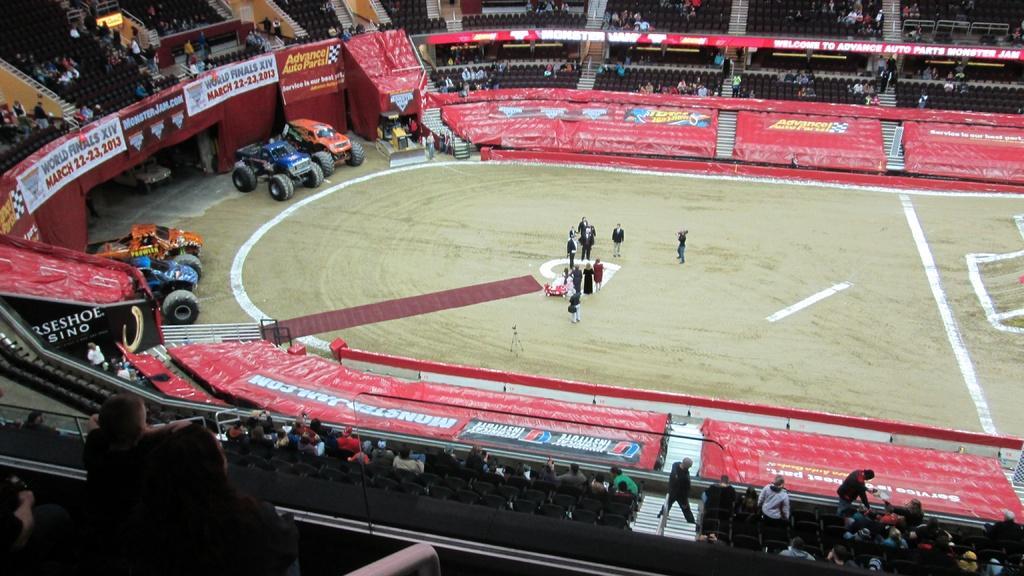Could you give a brief overview of what you see in this image? This is aerial view image of a play field with few people standing in the middle and monster trucks on the left side, there are many people sitting on the chairs and looking at the play field. 